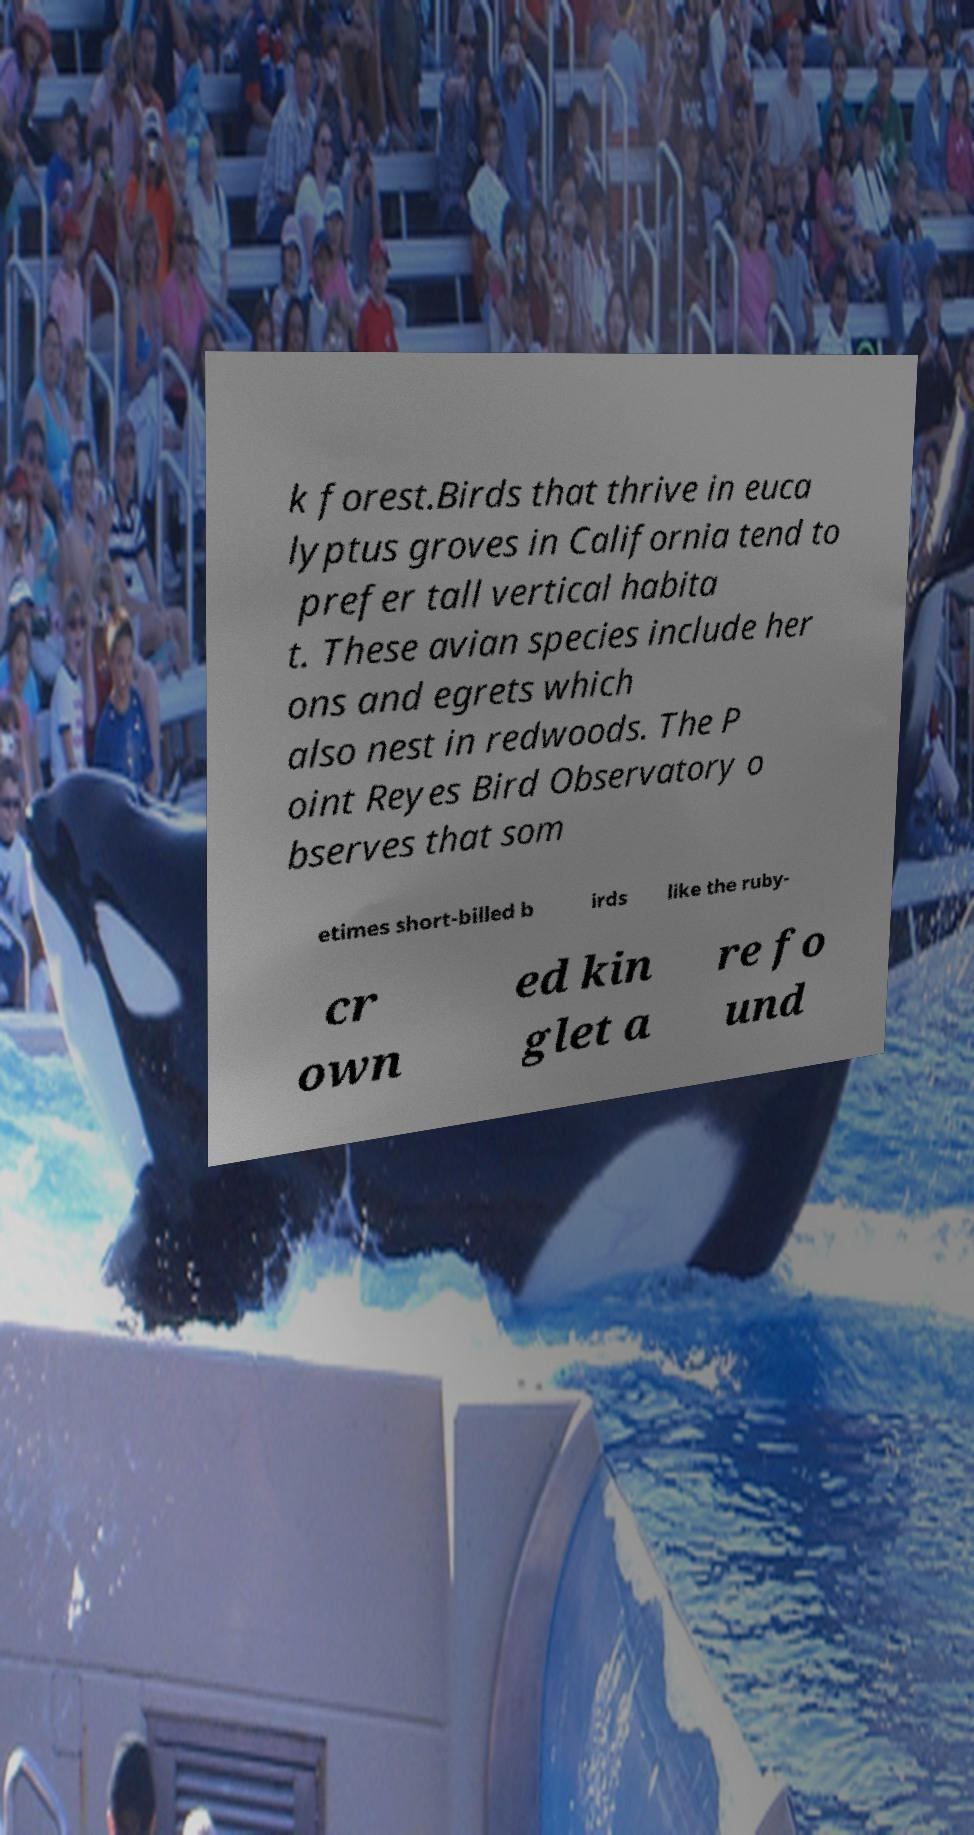Can you read and provide the text displayed in the image?This photo seems to have some interesting text. Can you extract and type it out for me? k forest.Birds that thrive in euca lyptus groves in California tend to prefer tall vertical habita t. These avian species include her ons and egrets which also nest in redwoods. The P oint Reyes Bird Observatory o bserves that som etimes short-billed b irds like the ruby- cr own ed kin glet a re fo und 